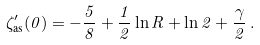<formula> <loc_0><loc_0><loc_500><loc_500>\zeta ^ { \prime } _ { \text {as} } ( 0 ) = - \frac { 5 } { 8 } + \frac { 1 } { 2 } \ln R + \ln 2 + \frac { \gamma } { 2 } \, { . }</formula> 